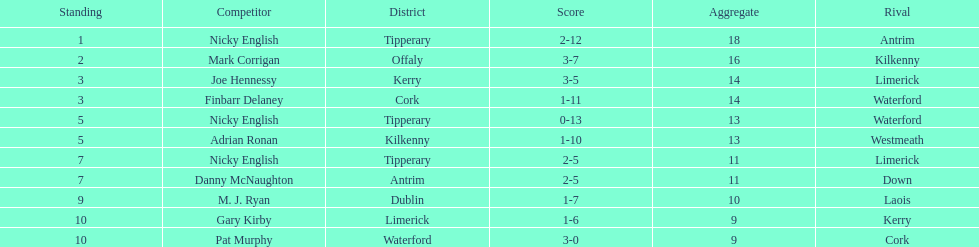What was the average of the totals of nicky english and mark corrigan? 17. 